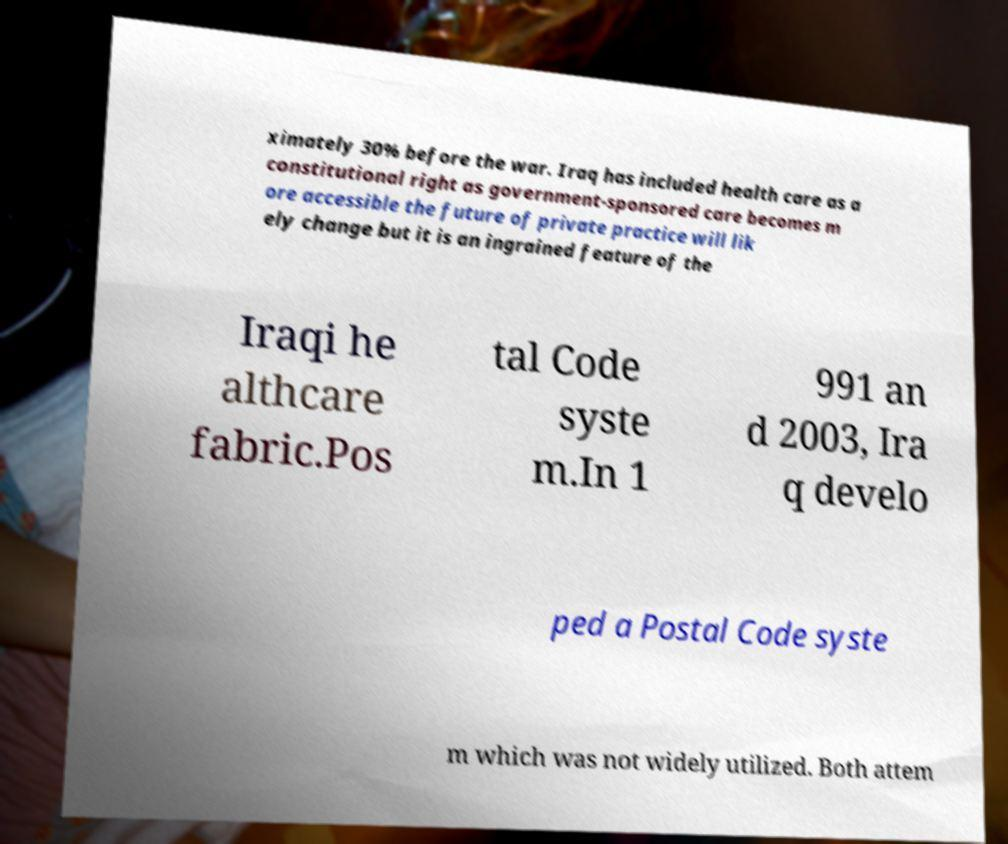Please identify and transcribe the text found in this image. ximately 30% before the war. Iraq has included health care as a constitutional right as government-sponsored care becomes m ore accessible the future of private practice will lik ely change but it is an ingrained feature of the Iraqi he althcare fabric.Pos tal Code syste m.In 1 991 an d 2003, Ira q develo ped a Postal Code syste m which was not widely utilized. Both attem 